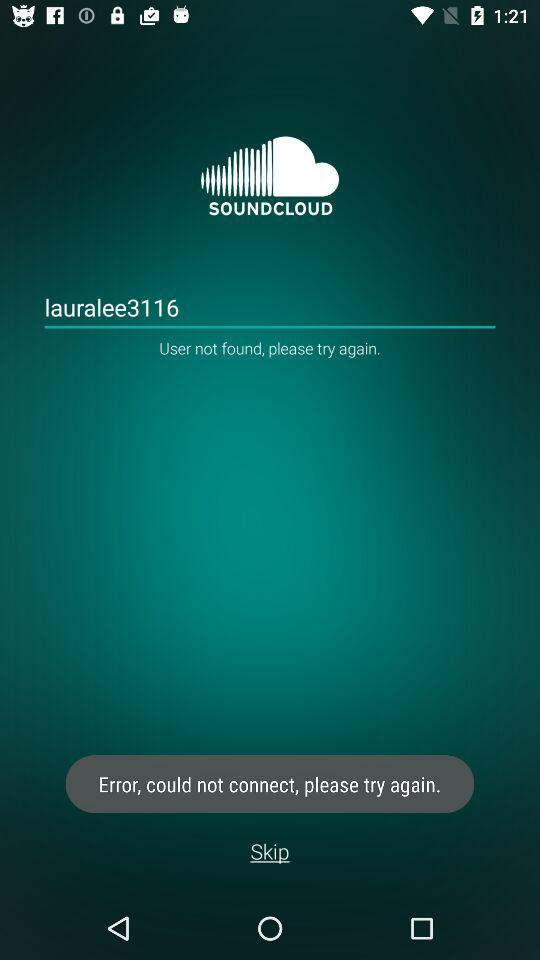How many errors are displayed?
Answer the question using a single word or phrase. 2 